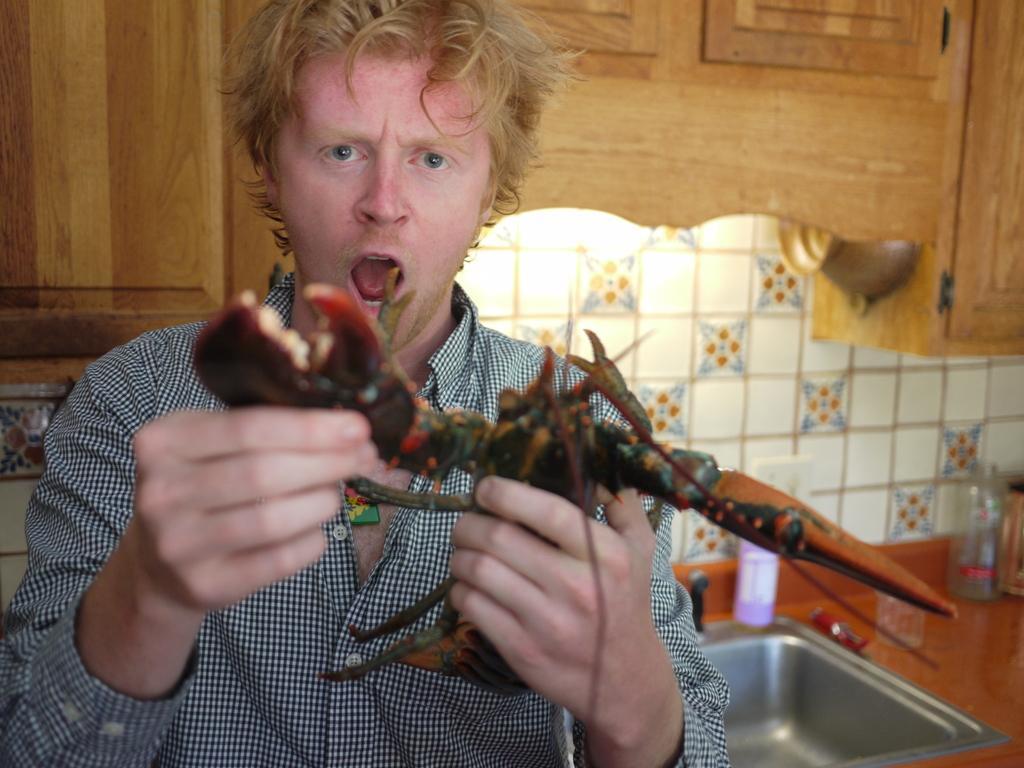How would you summarize this image in a sentence or two? In this image there is one man who is holding something, and in the background there is a wash basin and some jars, wall, light and wooden cupboard. 